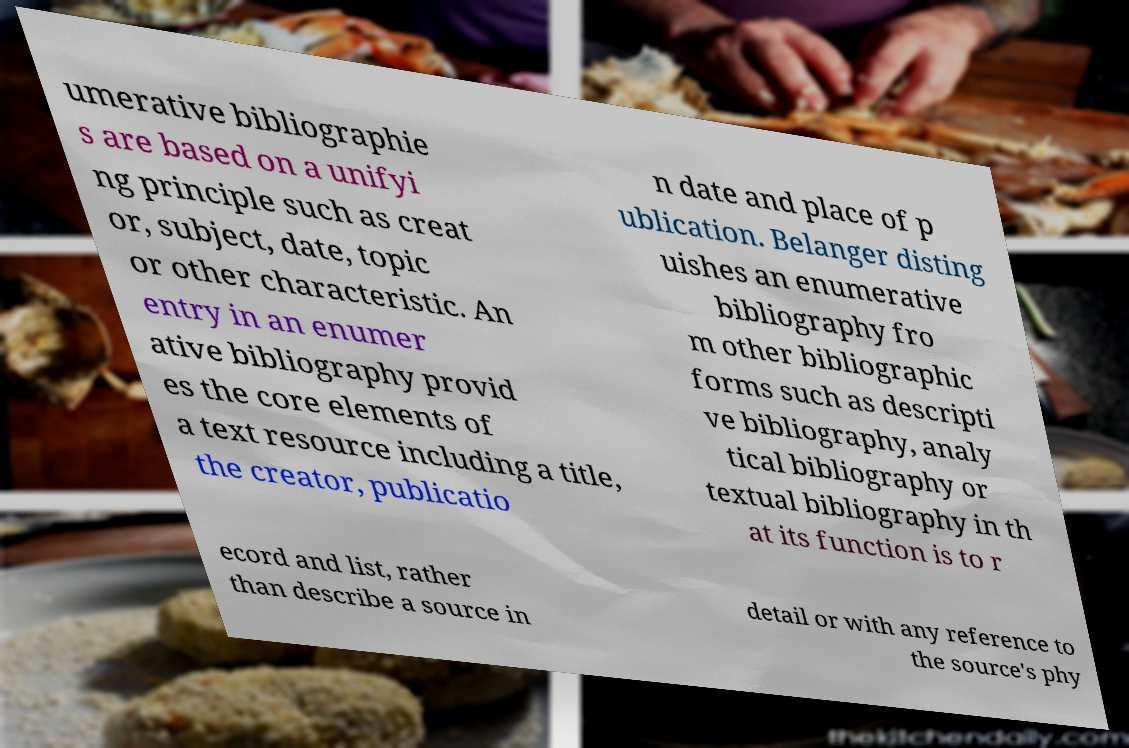What messages or text are displayed in this image? I need them in a readable, typed format. umerative bibliographie s are based on a unifyi ng principle such as creat or, subject, date, topic or other characteristic. An entry in an enumer ative bibliography provid es the core elements of a text resource including a title, the creator, publicatio n date and place of p ublication. Belanger disting uishes an enumerative bibliography fro m other bibliographic forms such as descripti ve bibliography, analy tical bibliography or textual bibliography in th at its function is to r ecord and list, rather than describe a source in detail or with any reference to the source's phy 